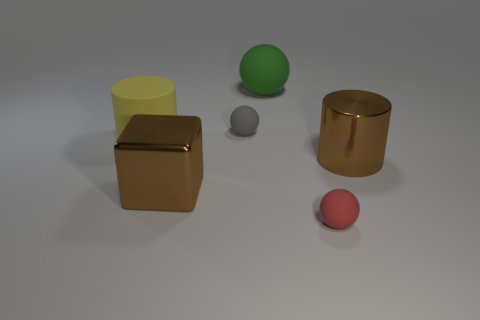Subtract 1 balls. How many balls are left? 2 Add 2 metal cubes. How many objects exist? 8 Subtract all cubes. How many objects are left? 5 Subtract all cyan metal objects. Subtract all brown metallic blocks. How many objects are left? 5 Add 3 gray matte balls. How many gray matte balls are left? 4 Add 1 brown shiny things. How many brown shiny things exist? 3 Subtract 0 green cylinders. How many objects are left? 6 